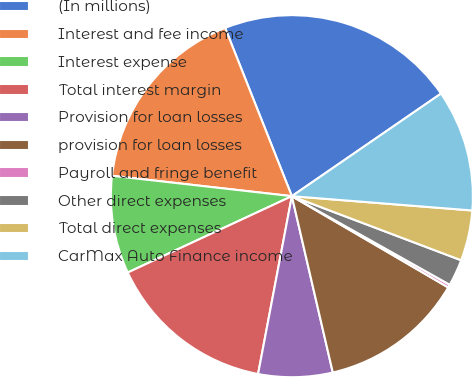Convert chart. <chart><loc_0><loc_0><loc_500><loc_500><pie_chart><fcel>(In millions)<fcel>Interest and fee income<fcel>Interest expense<fcel>Total interest margin<fcel>Provision for loan losses<fcel>provision for loan losses<fcel>Payroll and fringe benefit<fcel>Other direct expenses<fcel>Total direct expenses<fcel>CarMax Auto Finance income<nl><fcel>21.42%<fcel>17.19%<fcel>8.73%<fcel>15.08%<fcel>6.62%<fcel>12.96%<fcel>0.27%<fcel>2.38%<fcel>4.5%<fcel>10.85%<nl></chart> 